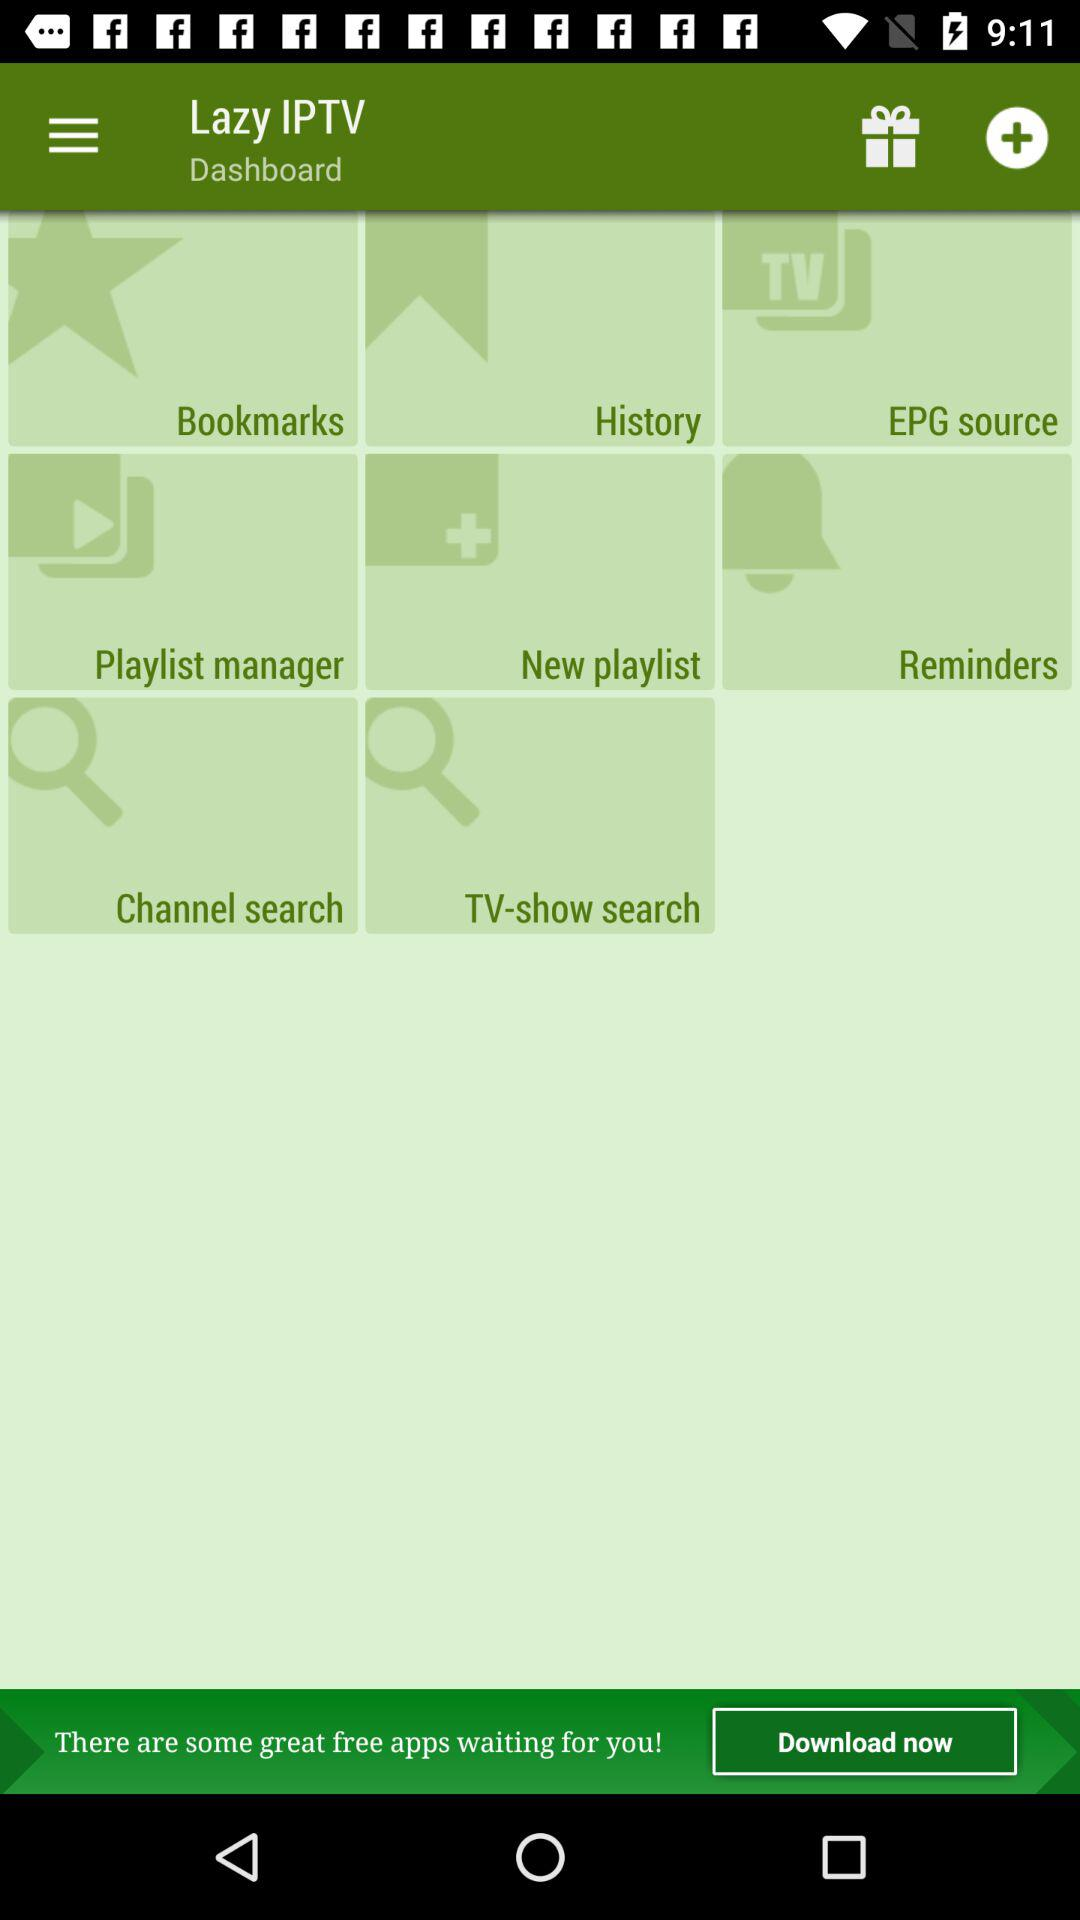What are the options available in the "Lazy IPTV" dashboard? The available options are "Bookmarks", "History", "EPG source", "Playlist manager", "New playlist", "Reminders", "Channel search" and "TV-show search". 